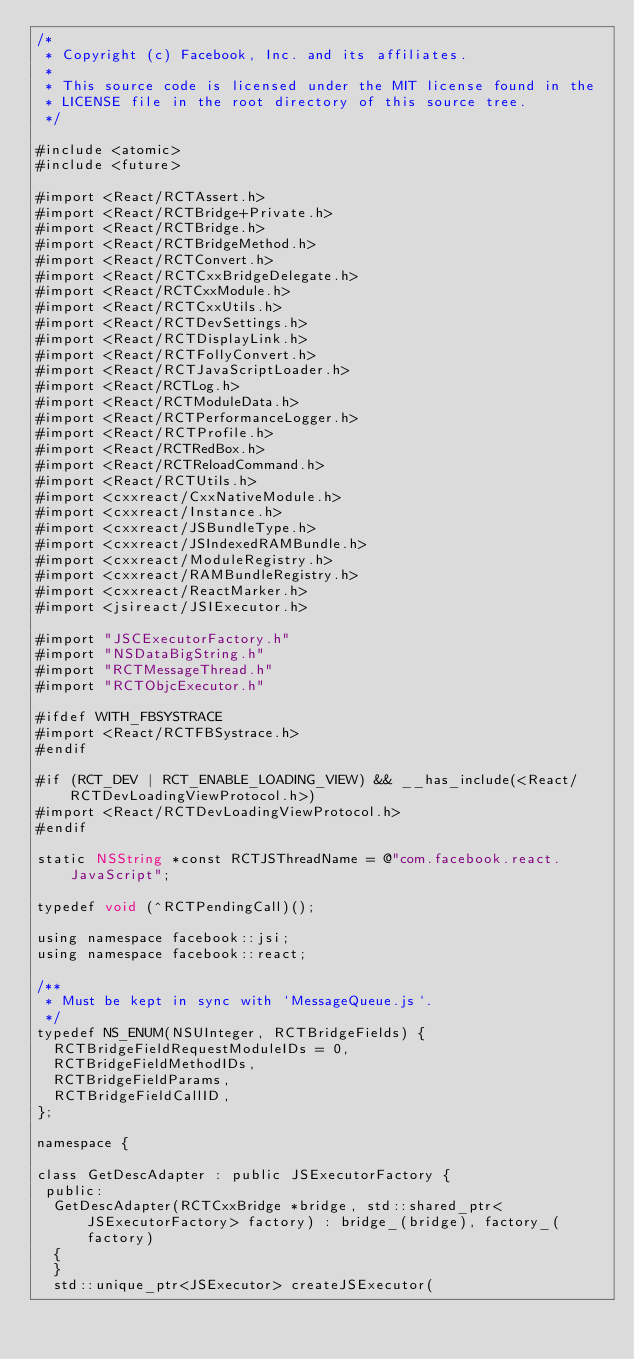<code> <loc_0><loc_0><loc_500><loc_500><_ObjectiveC_>/*
 * Copyright (c) Facebook, Inc. and its affiliates.
 *
 * This source code is licensed under the MIT license found in the
 * LICENSE file in the root directory of this source tree.
 */

#include <atomic>
#include <future>

#import <React/RCTAssert.h>
#import <React/RCTBridge+Private.h>
#import <React/RCTBridge.h>
#import <React/RCTBridgeMethod.h>
#import <React/RCTConvert.h>
#import <React/RCTCxxBridgeDelegate.h>
#import <React/RCTCxxModule.h>
#import <React/RCTCxxUtils.h>
#import <React/RCTDevSettings.h>
#import <React/RCTDisplayLink.h>
#import <React/RCTFollyConvert.h>
#import <React/RCTJavaScriptLoader.h>
#import <React/RCTLog.h>
#import <React/RCTModuleData.h>
#import <React/RCTPerformanceLogger.h>
#import <React/RCTProfile.h>
#import <React/RCTRedBox.h>
#import <React/RCTReloadCommand.h>
#import <React/RCTUtils.h>
#import <cxxreact/CxxNativeModule.h>
#import <cxxreact/Instance.h>
#import <cxxreact/JSBundleType.h>
#import <cxxreact/JSIndexedRAMBundle.h>
#import <cxxreact/ModuleRegistry.h>
#import <cxxreact/RAMBundleRegistry.h>
#import <cxxreact/ReactMarker.h>
#import <jsireact/JSIExecutor.h>

#import "JSCExecutorFactory.h"
#import "NSDataBigString.h"
#import "RCTMessageThread.h"
#import "RCTObjcExecutor.h"

#ifdef WITH_FBSYSTRACE
#import <React/RCTFBSystrace.h>
#endif

#if (RCT_DEV | RCT_ENABLE_LOADING_VIEW) && __has_include(<React/RCTDevLoadingViewProtocol.h>)
#import <React/RCTDevLoadingViewProtocol.h>
#endif

static NSString *const RCTJSThreadName = @"com.facebook.react.JavaScript";

typedef void (^RCTPendingCall)();

using namespace facebook::jsi;
using namespace facebook::react;

/**
 * Must be kept in sync with `MessageQueue.js`.
 */
typedef NS_ENUM(NSUInteger, RCTBridgeFields) {
  RCTBridgeFieldRequestModuleIDs = 0,
  RCTBridgeFieldMethodIDs,
  RCTBridgeFieldParams,
  RCTBridgeFieldCallID,
};

namespace {

class GetDescAdapter : public JSExecutorFactory {
 public:
  GetDescAdapter(RCTCxxBridge *bridge, std::shared_ptr<JSExecutorFactory> factory) : bridge_(bridge), factory_(factory)
  {
  }
  std::unique_ptr<JSExecutor> createJSExecutor(</code> 